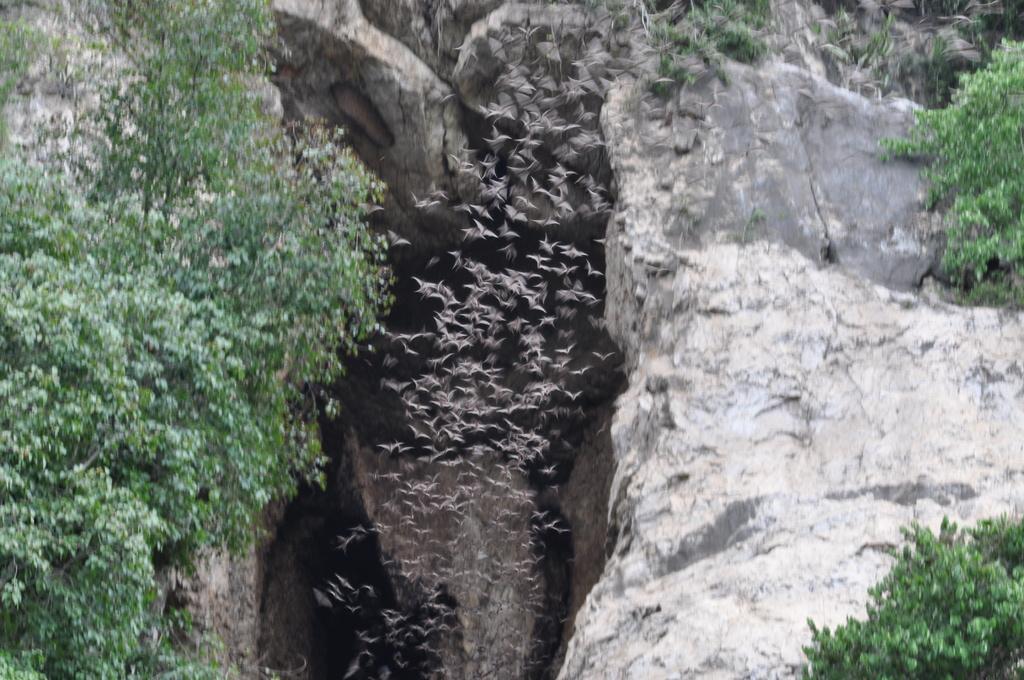Could you give a brief overview of what you see in this image? In this image there are trees, rocks and birds flying. 